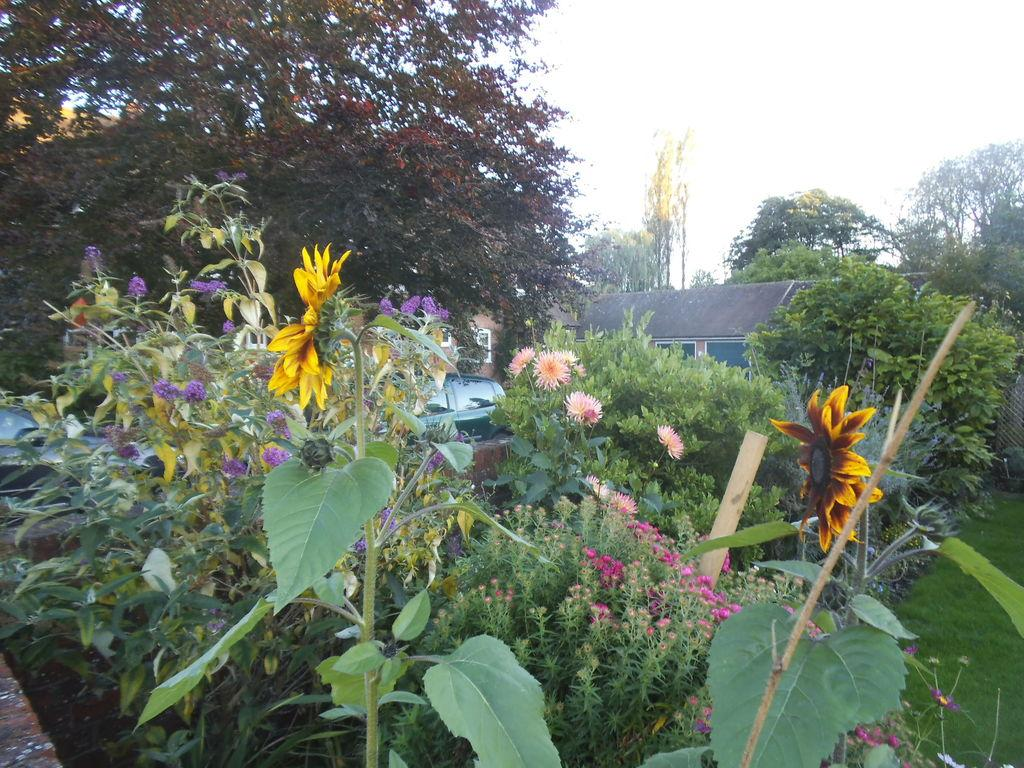What type of vegetation can be seen in the image? There are trees, plants, flowers, and grass in the image. What else is present in the image besides vegetation? There are vehicles and houses in the image. What can be seen in the sky in the image? The sky is visible in the image. Can you point to the wish that is floating in the image? There is no wish present in the image; it is not a magical scene. 